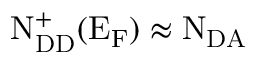<formula> <loc_0><loc_0><loc_500><loc_500>N _ { D D } ^ { + } ( E _ { F } ) \approx N _ { D A }</formula> 